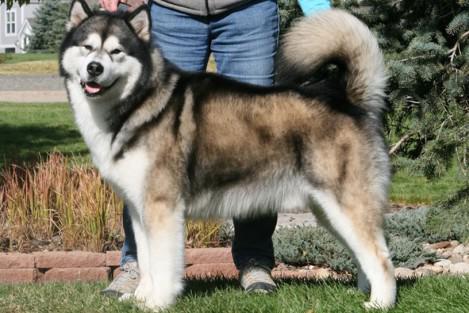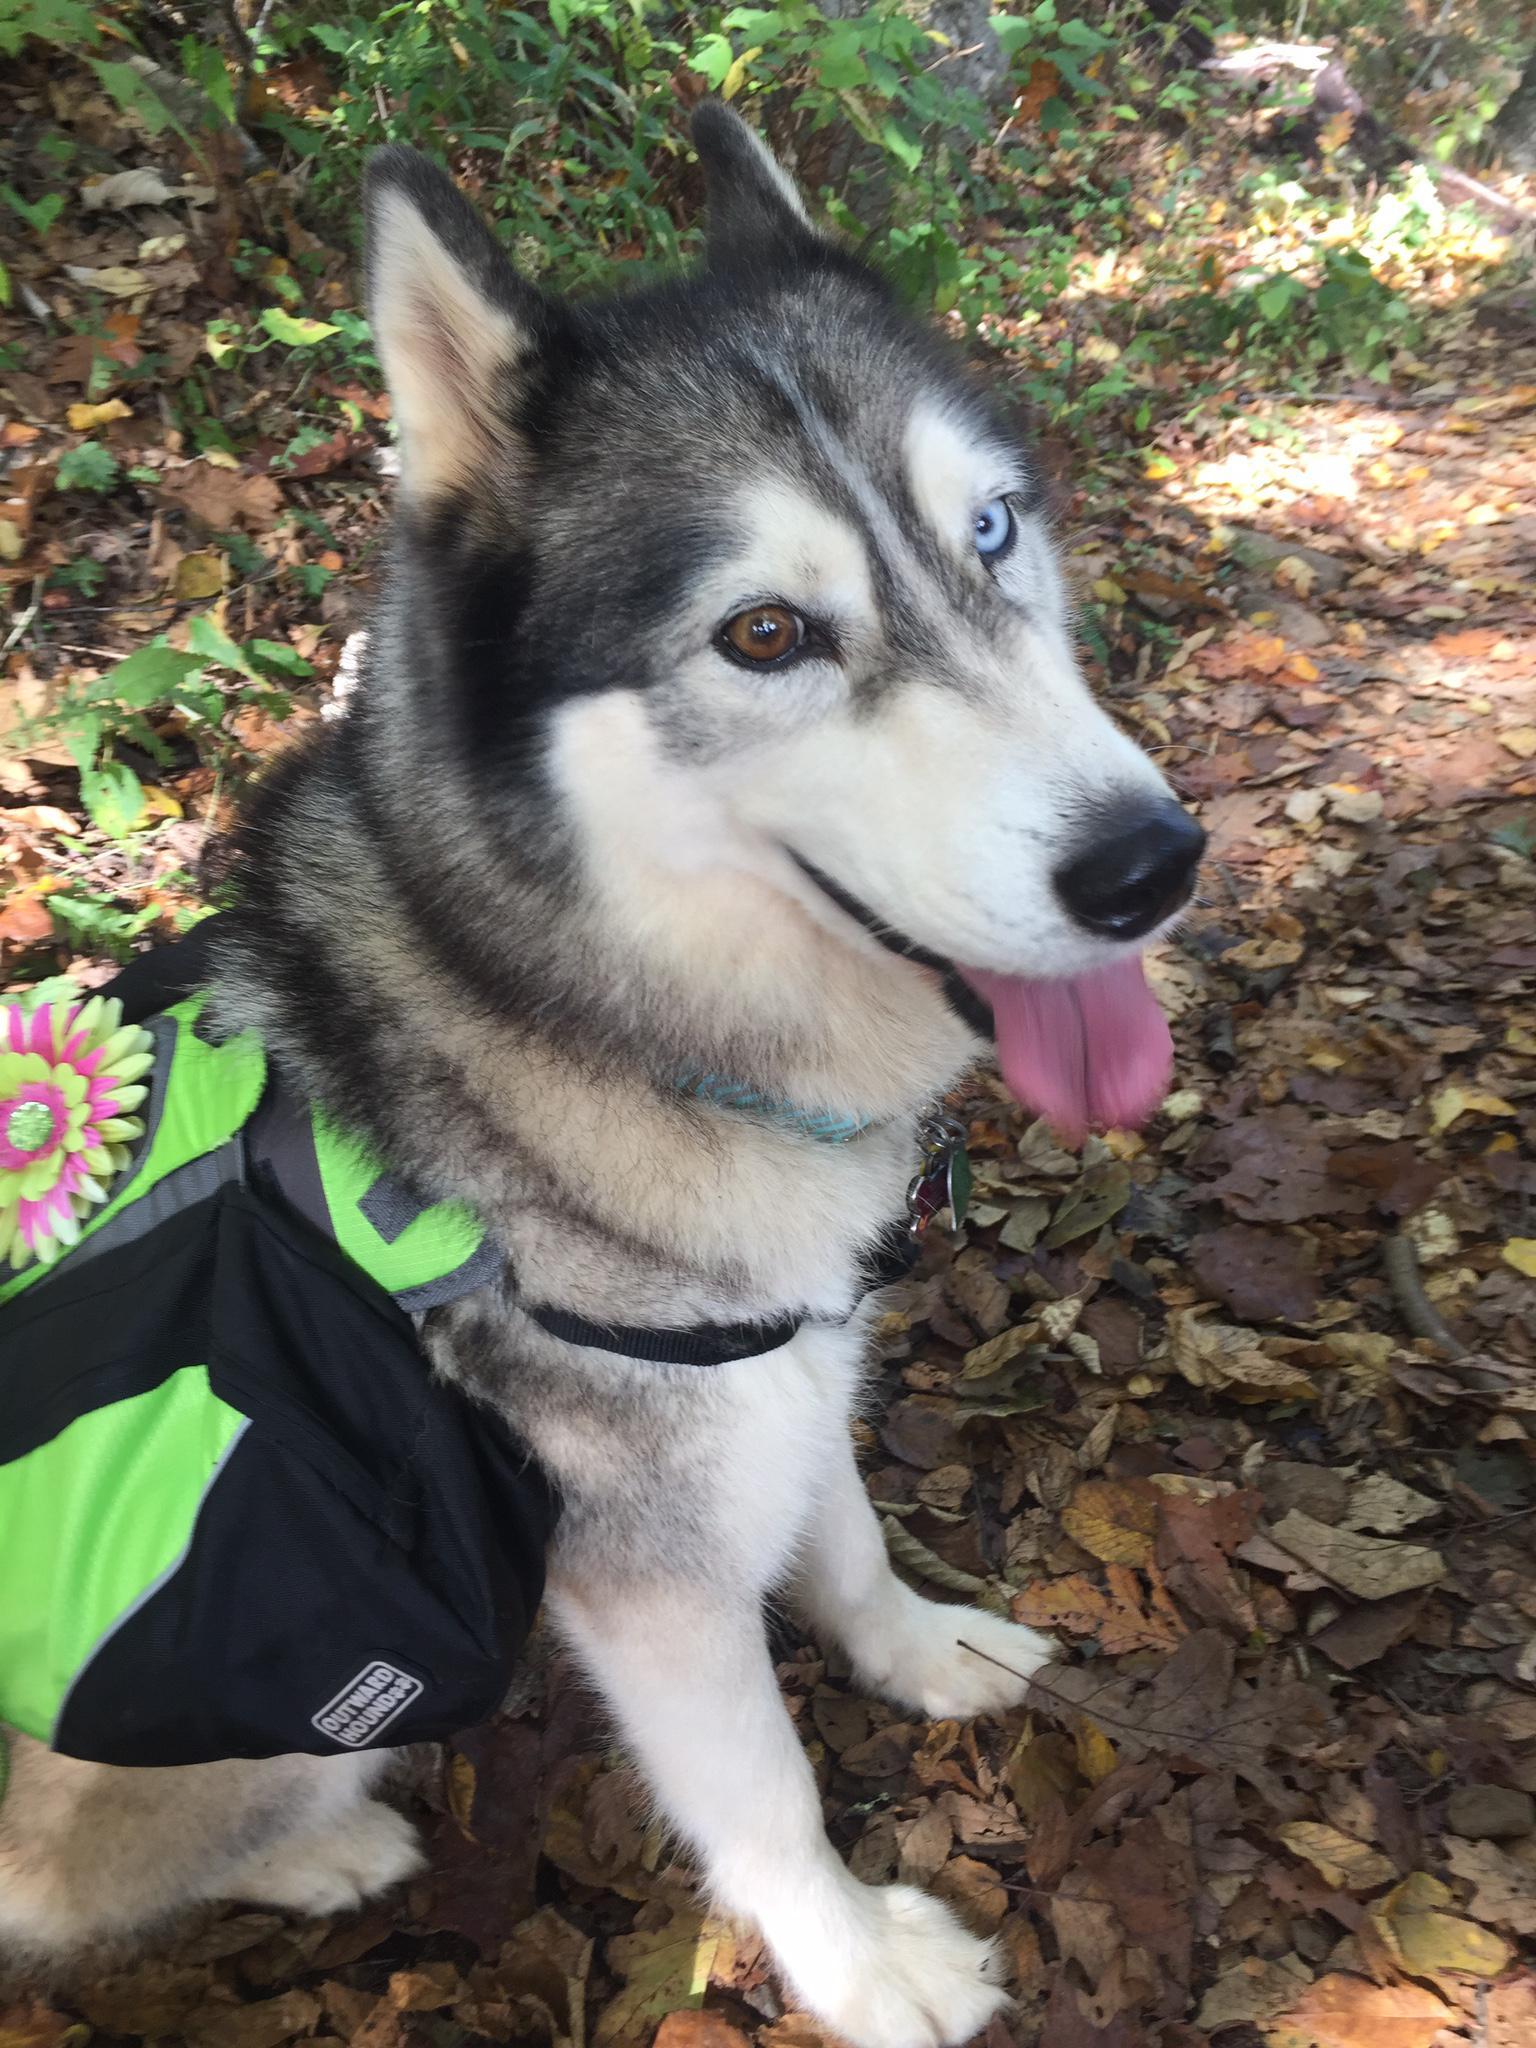The first image is the image on the left, the second image is the image on the right. Given the left and right images, does the statement "There are three dogs." hold true? Answer yes or no. No. 